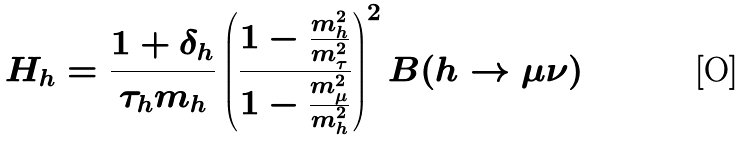<formula> <loc_0><loc_0><loc_500><loc_500>H _ { h } = \frac { 1 + \delta _ { h } } { \tau _ { h } m _ { h } } \left ( \frac { 1 - \frac { m _ { h } ^ { 2 } } { m _ { \tau } ^ { 2 } } } { 1 - \frac { m _ { \mu } ^ { 2 } } { m _ { h } ^ { 2 } } } \right ) ^ { 2 } B ( h \rightarrow \mu \nu )</formula> 